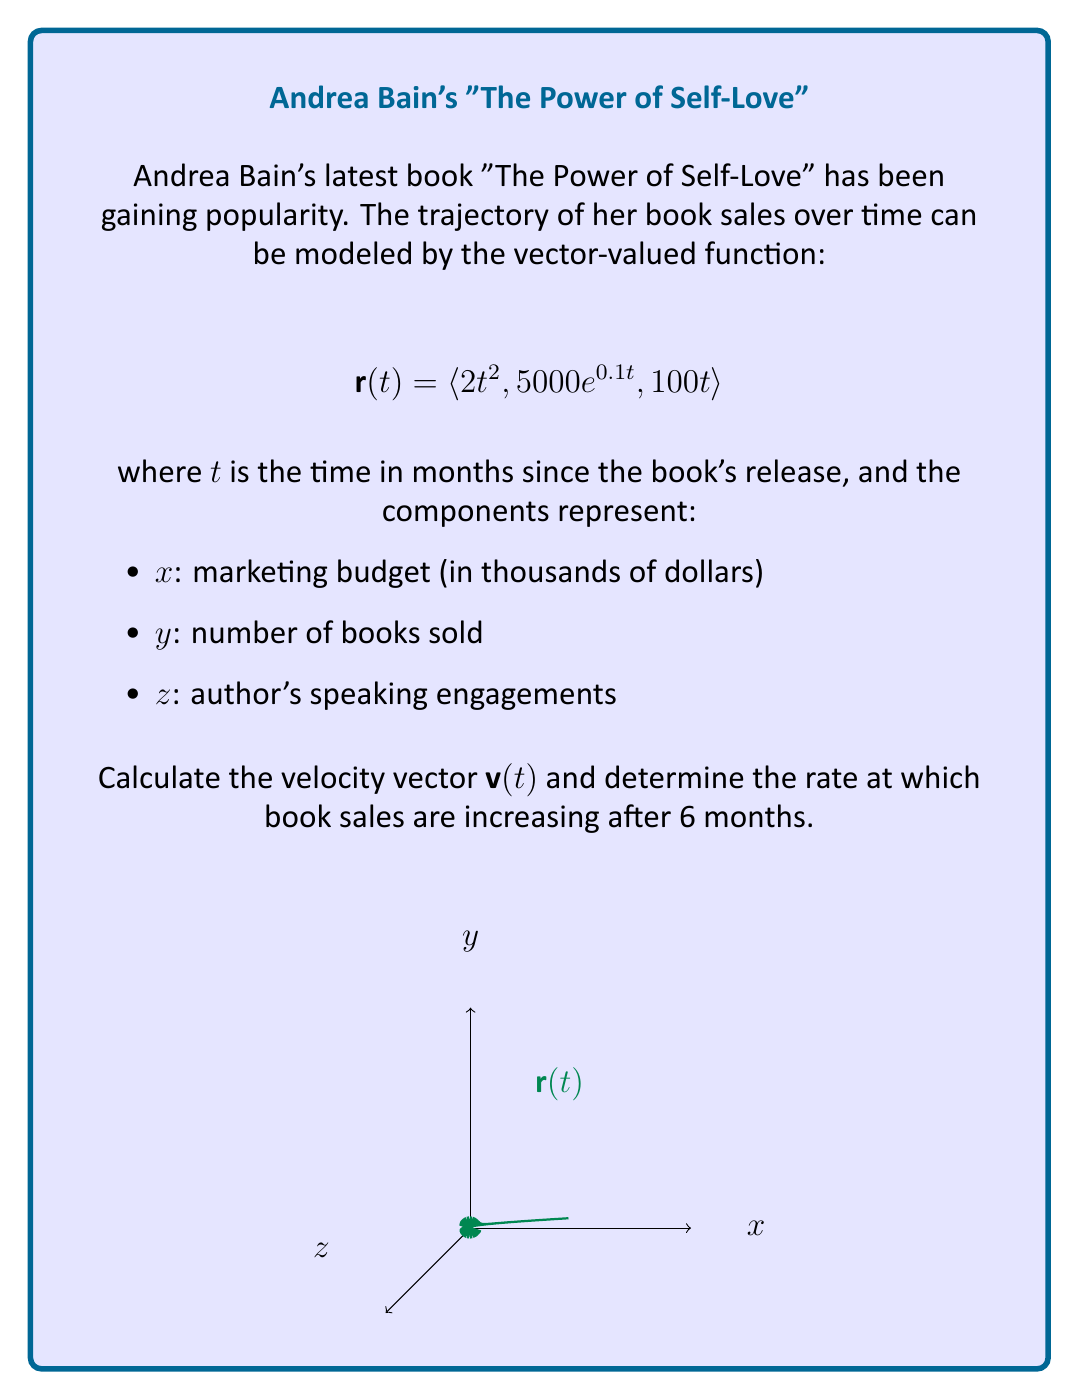Could you help me with this problem? To solve this problem, we'll follow these steps:

1) First, we need to find the velocity vector $\mathbf{v}(t)$. The velocity vector is the derivative of the position vector $\mathbf{r}(t)$:

   $$\mathbf{v}(t) = \frac{d}{dt}\mathbf{r}(t) = \langle \frac{d}{dt}(2t^2), \frac{d}{dt}(5000e^{0.1t}), \frac{d}{dt}(100t) \rangle$$

2) Let's calculate each component:
   - $\frac{d}{dt}(2t^2) = 4t$
   - $\frac{d}{dt}(5000e^{0.1t}) = 5000 \cdot 0.1 \cdot e^{0.1t} = 500e^{0.1t}$
   - $\frac{d}{dt}(100t) = 100$

3) Therefore, the velocity vector is:
   $$\mathbf{v}(t) = \langle 4t, 500e^{0.1t}, 100 \rangle$$

4) The question asks about the rate at which book sales are increasing after 6 months. This corresponds to the y-component of the velocity vector at $t=6$:

   $$\frac{dy}{dt}\bigg|_{t=6} = 500e^{0.1 \cdot 6} = 500e^{0.6}$$

5) Calculate this value:
   $$500e^{0.6} \approx 912.84$$

Therefore, after 6 months, book sales are increasing at a rate of approximately 913 books per month.
Answer: $913$ books/month 